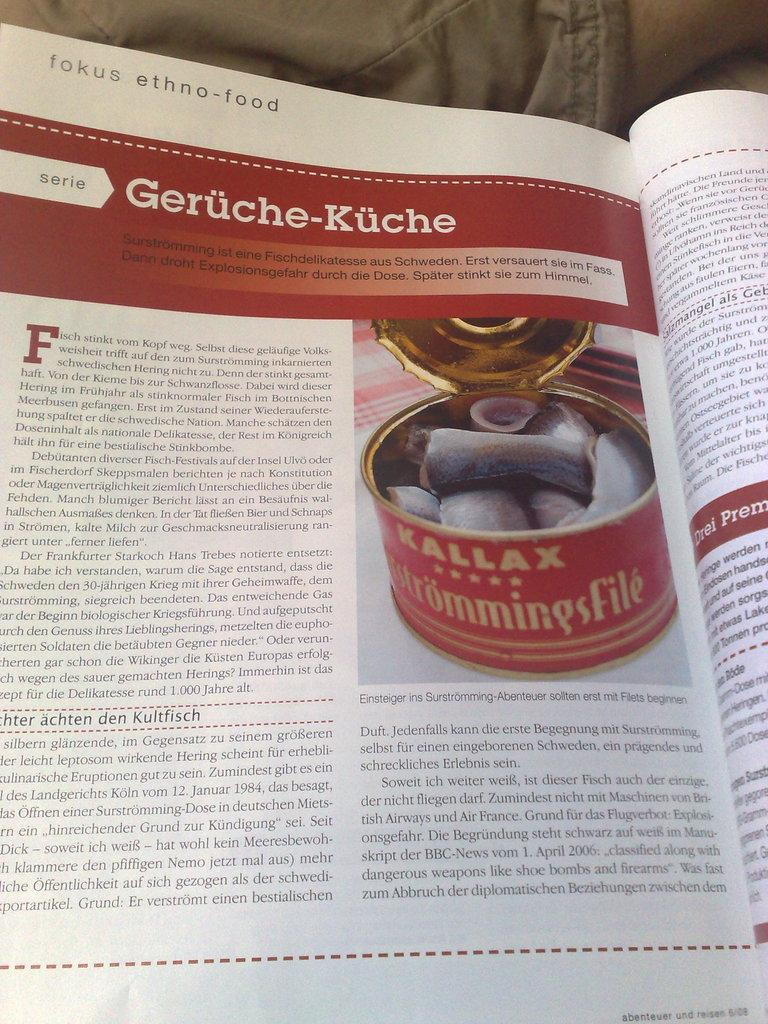<image>
Share a concise interpretation of the image provided. A person is reading a book called fokus ethno-food. 